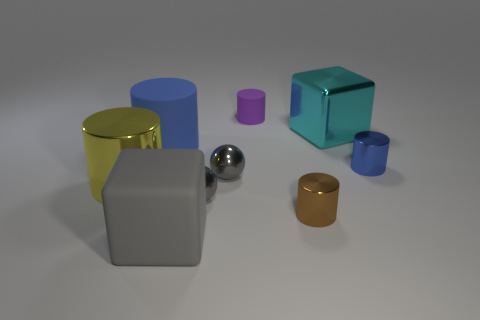What number of cylinders are brown shiny objects or tiny gray metallic objects?
Keep it short and to the point. 1. There is a rubber cylinder on the left side of the purple thing; how many large shiny things are on the left side of it?
Make the answer very short. 1. Does the large yellow thing have the same material as the small blue thing?
Provide a succinct answer. Yes. Are there any gray things that have the same material as the small purple object?
Make the answer very short. Yes. What color is the sphere that is in front of the metal object to the left of the big cube to the left of the purple rubber cylinder?
Provide a short and direct response. Gray. What number of yellow objects are either metal spheres or metallic cubes?
Offer a terse response. 0. What number of other small objects have the same shape as the cyan thing?
Ensure brevity in your answer.  0. What shape is the yellow metal thing that is the same size as the gray matte thing?
Your answer should be compact. Cylinder. Are there any tiny matte things to the right of the small blue shiny thing?
Ensure brevity in your answer.  No. There is a large block that is in front of the shiny cube; is there a blue metal thing that is in front of it?
Offer a very short reply. No. 